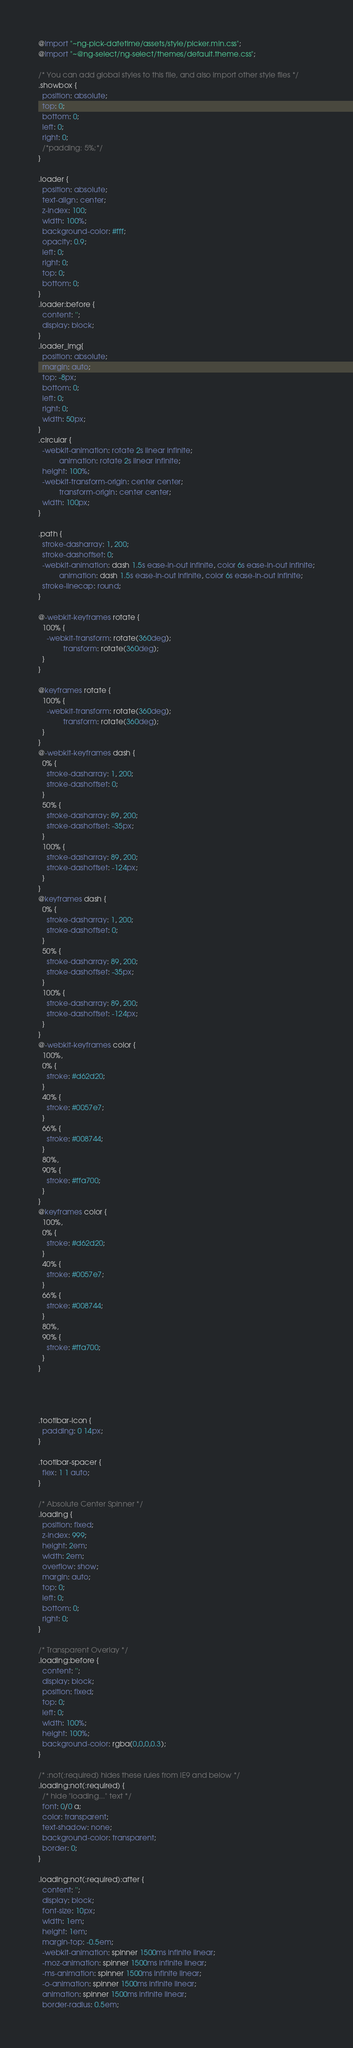Convert code to text. <code><loc_0><loc_0><loc_500><loc_500><_CSS_>@import "~ng-pick-datetime/assets/style/picker.min.css";
@import "~@ng-select/ng-select/themes/default.theme.css";

/* You can add global styles to this file, and also import other style files */
.showbox {
  position: absolute;
  top: 0;
  bottom: 0;
  left: 0;
  right: 0;
  /*padding: 5%;*/
}

.loader {
  position: absolute;
  text-align: center;
  z-index: 100;
  width: 100%;
  background-color: #fff;
  opacity: 0.9;
  left: 0;
  right: 0;
  top: 0;
  bottom: 0;
}
.loader:before {
  content: '';
  display: block;
}
.loader_img{
  position: absolute;
  margin: auto;
  top: -8px;
  bottom: 0;
  left: 0;
  right: 0;
  width: 50px;
}
.circular {
  -webkit-animation: rotate 2s linear infinite;
          animation: rotate 2s linear infinite;
  height: 100%;
  -webkit-transform-origin: center center;
          transform-origin: center center;
  width: 100px;
}

.path {
  stroke-dasharray: 1, 200;
  stroke-dashoffset: 0;
  -webkit-animation: dash 1.5s ease-in-out infinite, color 6s ease-in-out infinite;
          animation: dash 1.5s ease-in-out infinite, color 6s ease-in-out infinite;
  stroke-linecap: round;
}

@-webkit-keyframes rotate {
  100% {
    -webkit-transform: rotate(360deg);
            transform: rotate(360deg);
  }
}

@keyframes rotate {
  100% {
    -webkit-transform: rotate(360deg);
            transform: rotate(360deg);
  }
}
@-webkit-keyframes dash {
  0% {
    stroke-dasharray: 1, 200;
    stroke-dashoffset: 0;
  }
  50% {
    stroke-dasharray: 89, 200;
    stroke-dashoffset: -35px;
  }
  100% {
    stroke-dasharray: 89, 200;
    stroke-dashoffset: -124px;
  }
}
@keyframes dash {
  0% {
    stroke-dasharray: 1, 200;
    stroke-dashoffset: 0;
  }
  50% {
    stroke-dasharray: 89, 200;
    stroke-dashoffset: -35px;
  }
  100% {
    stroke-dasharray: 89, 200;
    stroke-dashoffset: -124px;
  }
}
@-webkit-keyframes color {
  100%,
  0% {
    stroke: #d62d20;
  }
  40% {
    stroke: #0057e7;
  }
  66% {
    stroke: #008744;
  }
  80%,
  90% {
    stroke: #ffa700;
  }
}
@keyframes color {
  100%,
  0% {
    stroke: #d62d20;
  }
  40% {
    stroke: #0057e7;
  }
  66% {
    stroke: #008744;
  }
  80%,
  90% {
    stroke: #ffa700;
  }
}




.tootlbar-icon {
  padding: 0 14px;
}

.tootlbar-spacer {
  flex: 1 1 auto;
}

/* Absolute Center Spinner */
.loading {
  position: fixed;
  z-index: 999;
  height: 2em;
  width: 2em;
  overflow: show;
  margin: auto;
  top: 0;
  left: 0;
  bottom: 0;
  right: 0;
}

/* Transparent Overlay */
.loading:before {
  content: '';
  display: block;
  position: fixed;
  top: 0;
  left: 0;
  width: 100%;
  height: 100%;
  background-color: rgba(0,0,0,0.3);
}

/* :not(:required) hides these rules from IE9 and below */
.loading:not(:required) {
  /* hide "loading..." text */
  font: 0/0 a;
  color: transparent;
  text-shadow: none;
  background-color: transparent;
  border: 0;
}

.loading:not(:required):after {
  content: '';
  display: block;
  font-size: 10px;
  width: 1em;
  height: 1em;
  margin-top: -0.5em;
  -webkit-animation: spinner 1500ms infinite linear;
  -moz-animation: spinner 1500ms infinite linear;
  -ms-animation: spinner 1500ms infinite linear;
  -o-animation: spinner 1500ms infinite linear;
  animation: spinner 1500ms infinite linear;
  border-radius: 0.5em;</code> 